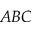Convert formula to latex. <formula><loc_0><loc_0><loc_500><loc_500>A B C</formula> 